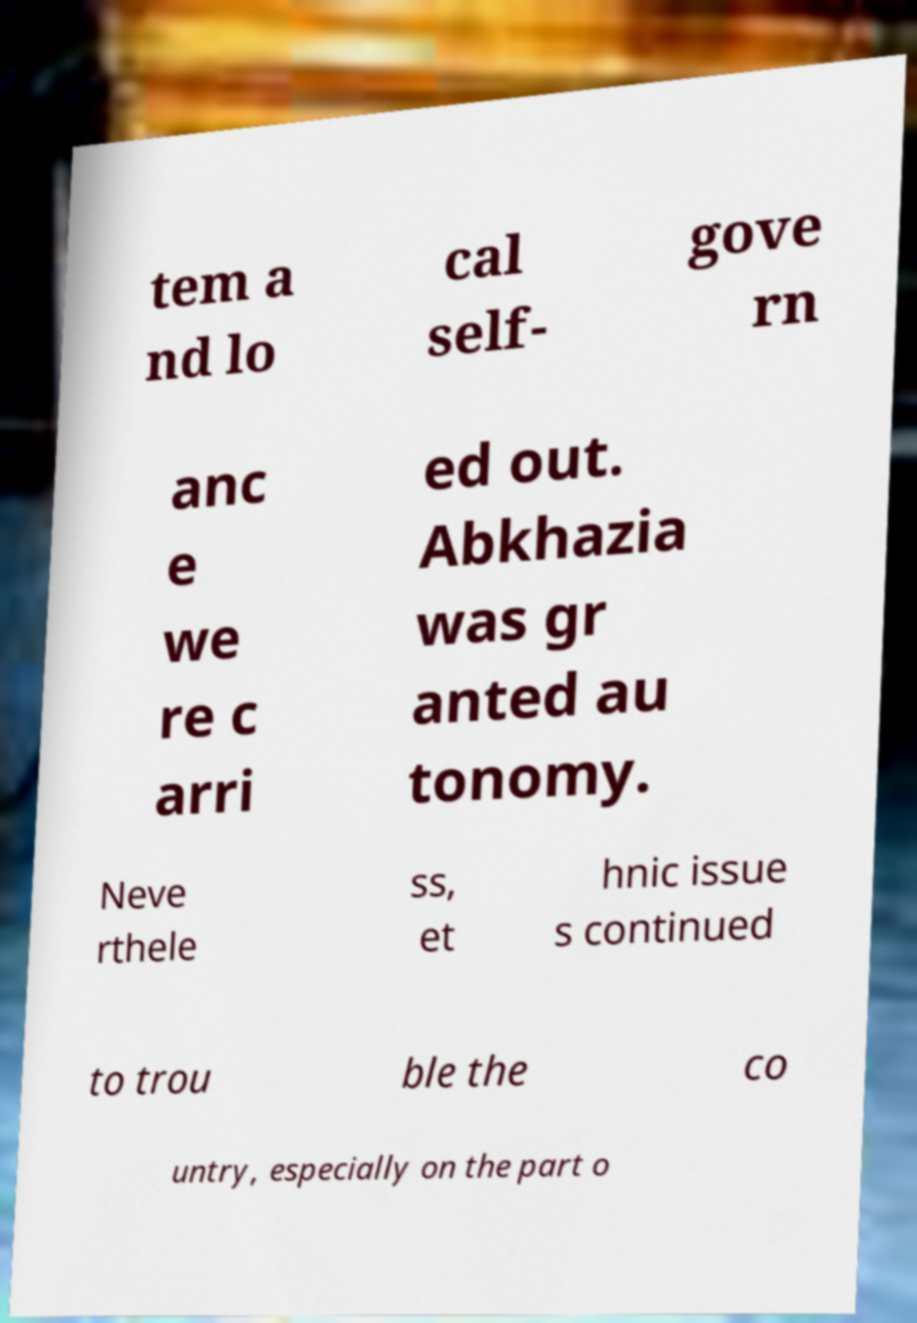I need the written content from this picture converted into text. Can you do that? tem a nd lo cal self- gove rn anc e we re c arri ed out. Abkhazia was gr anted au tonomy. Neve rthele ss, et hnic issue s continued to trou ble the co untry, especially on the part o 